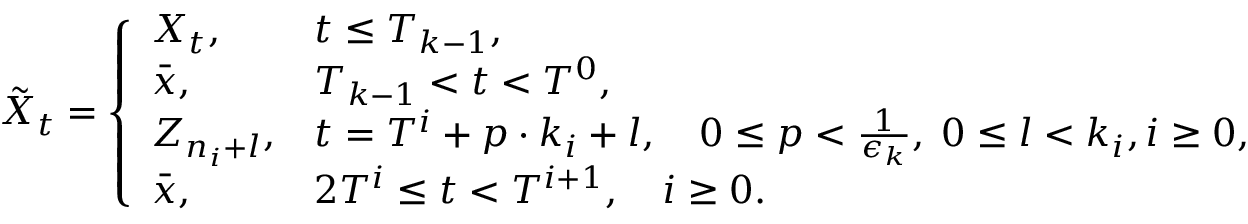Convert formula to latex. <formula><loc_0><loc_0><loc_500><loc_500>\tilde { X } _ { t } = \left \{ \begin{array} { l l } { X _ { t } , } & { t \leq T _ { k - 1 } , } \\ { \bar { x } , } & { T _ { k - 1 } < t < T ^ { 0 } , } \\ { Z _ { n _ { i } + l } , } & { t = T ^ { i } + p \cdot k _ { i } + l , \quad 0 \leq p < \frac { 1 } { \epsilon _ { k } } , \, 0 \leq l < k _ { i } , i \geq 0 , } \\ { \bar { x } , } & { 2 T ^ { i } \leq t < T ^ { i + 1 } , \quad i \geq 0 . } \end{array}</formula> 